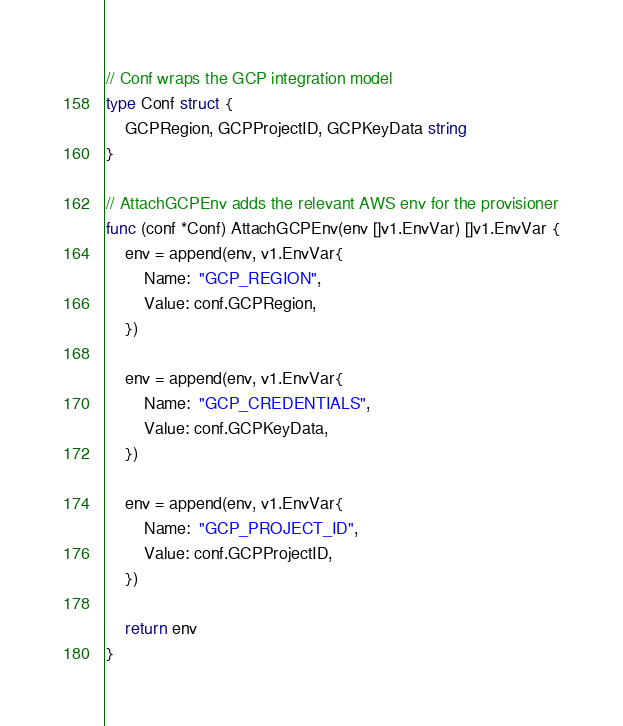<code> <loc_0><loc_0><loc_500><loc_500><_Go_>
// Conf wraps the GCP integration model
type Conf struct {
	GCPRegion, GCPProjectID, GCPKeyData string
}

// AttachGCPEnv adds the relevant AWS env for the provisioner
func (conf *Conf) AttachGCPEnv(env []v1.EnvVar) []v1.EnvVar {
	env = append(env, v1.EnvVar{
		Name:  "GCP_REGION",
		Value: conf.GCPRegion,
	})

	env = append(env, v1.EnvVar{
		Name:  "GCP_CREDENTIALS",
		Value: conf.GCPKeyData,
	})

	env = append(env, v1.EnvVar{
		Name:  "GCP_PROJECT_ID",
		Value: conf.GCPProjectID,
	})

	return env
}
</code> 